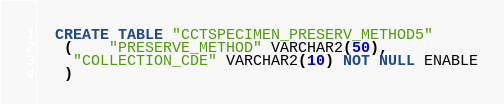Convert code to text. <code><loc_0><loc_0><loc_500><loc_500><_SQL_>
  CREATE TABLE "CCTSPECIMEN_PRESERV_METHOD5" 
   (	"PRESERVE_METHOD" VARCHAR2(50), 
	"COLLECTION_CDE" VARCHAR2(10) NOT NULL ENABLE
   ) </code> 